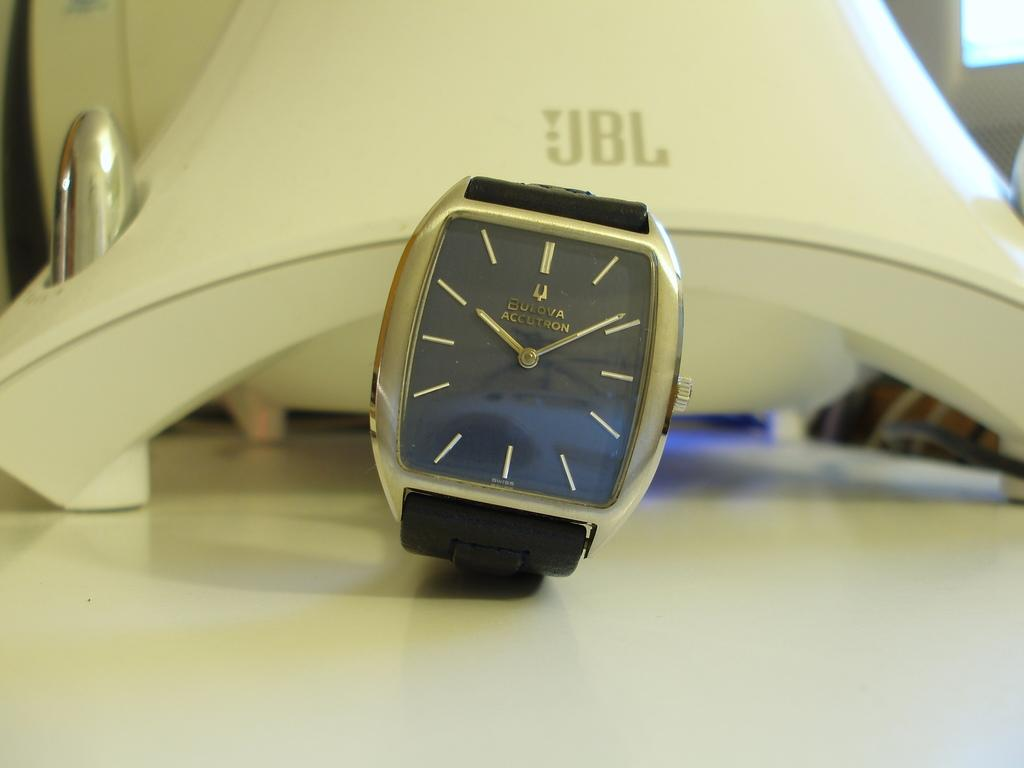<image>
Relay a brief, clear account of the picture shown. A silver and black Bulova Accutron watch on a table. 